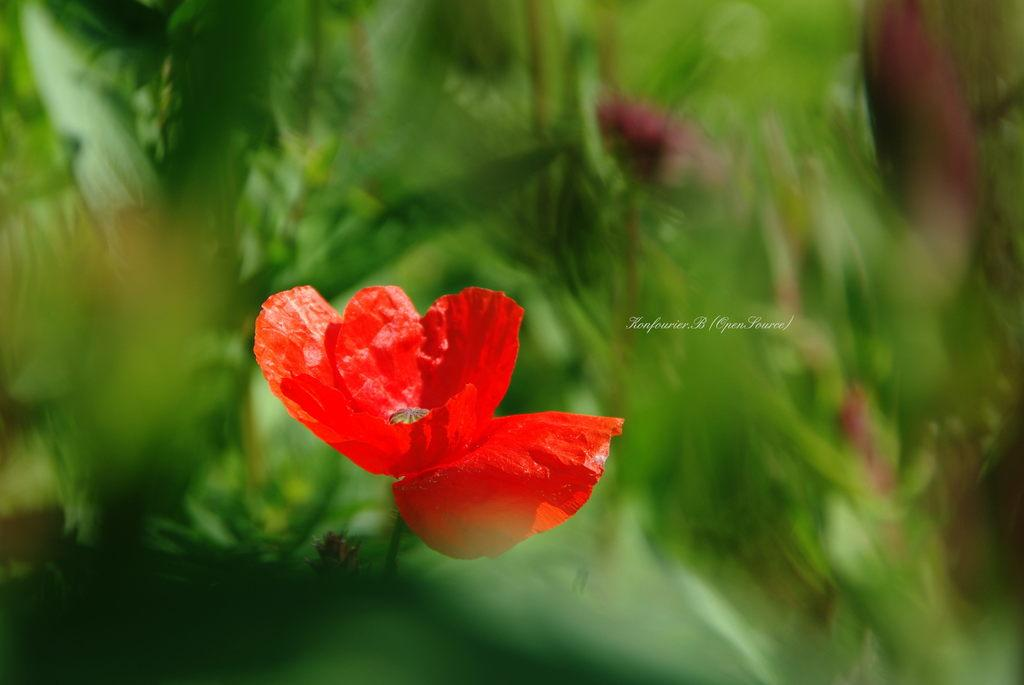What is located in the center of the image? There is a watermark and a flower in the center of the image. What color is the flower in the image? The flower is red in color. What can be seen in the background of the image? There are plants visible in the background of the image. What type of pickle is being used to create the watermark in the image? There is no pickle present in the image, and the watermark is not created using a pickle. 